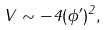<formula> <loc_0><loc_0><loc_500><loc_500>V \sim - 4 ( \phi ^ { \prime } ) ^ { 2 } ,</formula> 